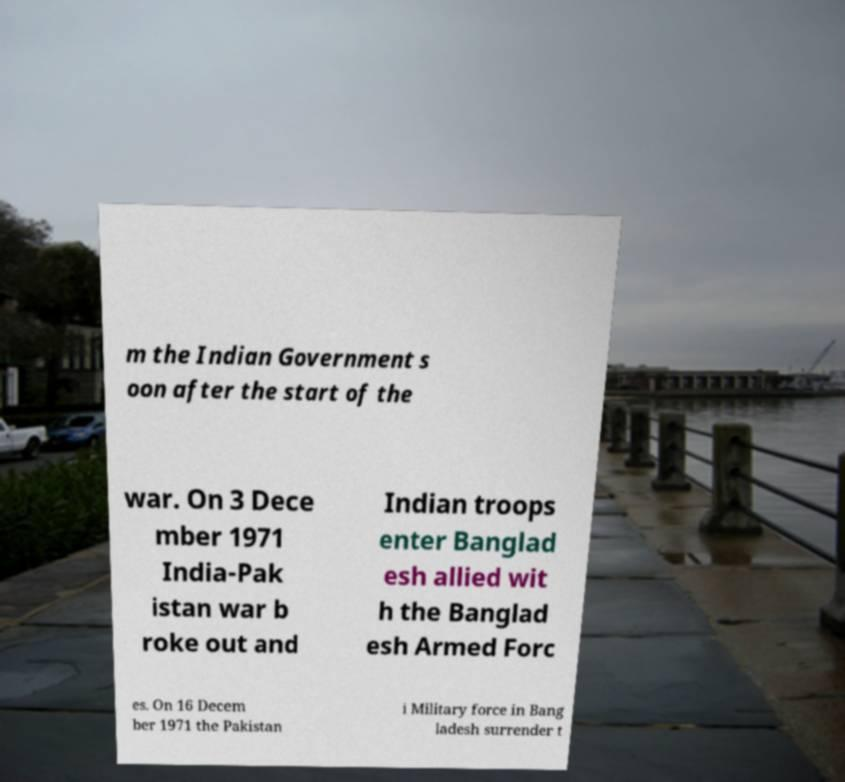Please read and relay the text visible in this image. What does it say? m the Indian Government s oon after the start of the war. On 3 Dece mber 1971 India-Pak istan war b roke out and Indian troops enter Banglad esh allied wit h the Banglad esh Armed Forc es. On 16 Decem ber 1971 the Pakistan i Military force in Bang ladesh surrender t 